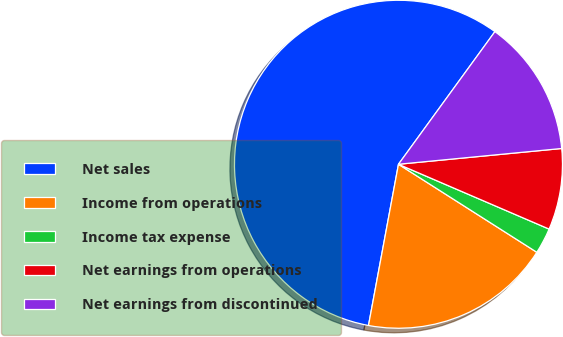Convert chart to OTSL. <chart><loc_0><loc_0><loc_500><loc_500><pie_chart><fcel>Net sales<fcel>Income from operations<fcel>Income tax expense<fcel>Net earnings from operations<fcel>Net earnings from discontinued<nl><fcel>57.08%<fcel>18.91%<fcel>2.55%<fcel>8.0%<fcel>13.46%<nl></chart> 